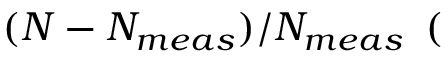Convert formula to latex. <formula><loc_0><loc_0><loc_500><loc_500>( N - N _ { m e a s } ) / N _ { m e a s } \, ( \</formula> 